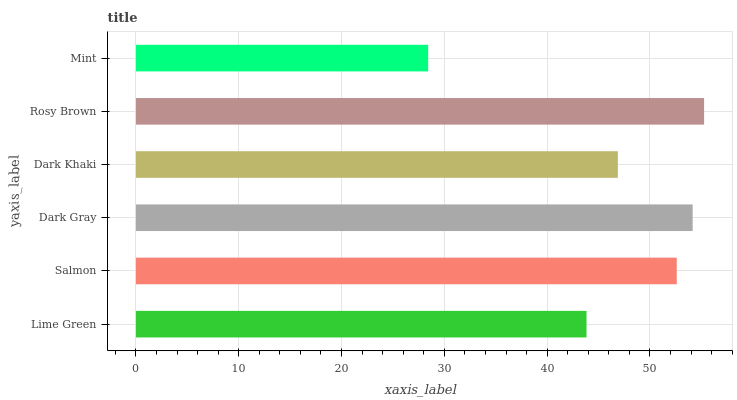Is Mint the minimum?
Answer yes or no. Yes. Is Rosy Brown the maximum?
Answer yes or no. Yes. Is Salmon the minimum?
Answer yes or no. No. Is Salmon the maximum?
Answer yes or no. No. Is Salmon greater than Lime Green?
Answer yes or no. Yes. Is Lime Green less than Salmon?
Answer yes or no. Yes. Is Lime Green greater than Salmon?
Answer yes or no. No. Is Salmon less than Lime Green?
Answer yes or no. No. Is Salmon the high median?
Answer yes or no. Yes. Is Dark Khaki the low median?
Answer yes or no. Yes. Is Lime Green the high median?
Answer yes or no. No. Is Lime Green the low median?
Answer yes or no. No. 